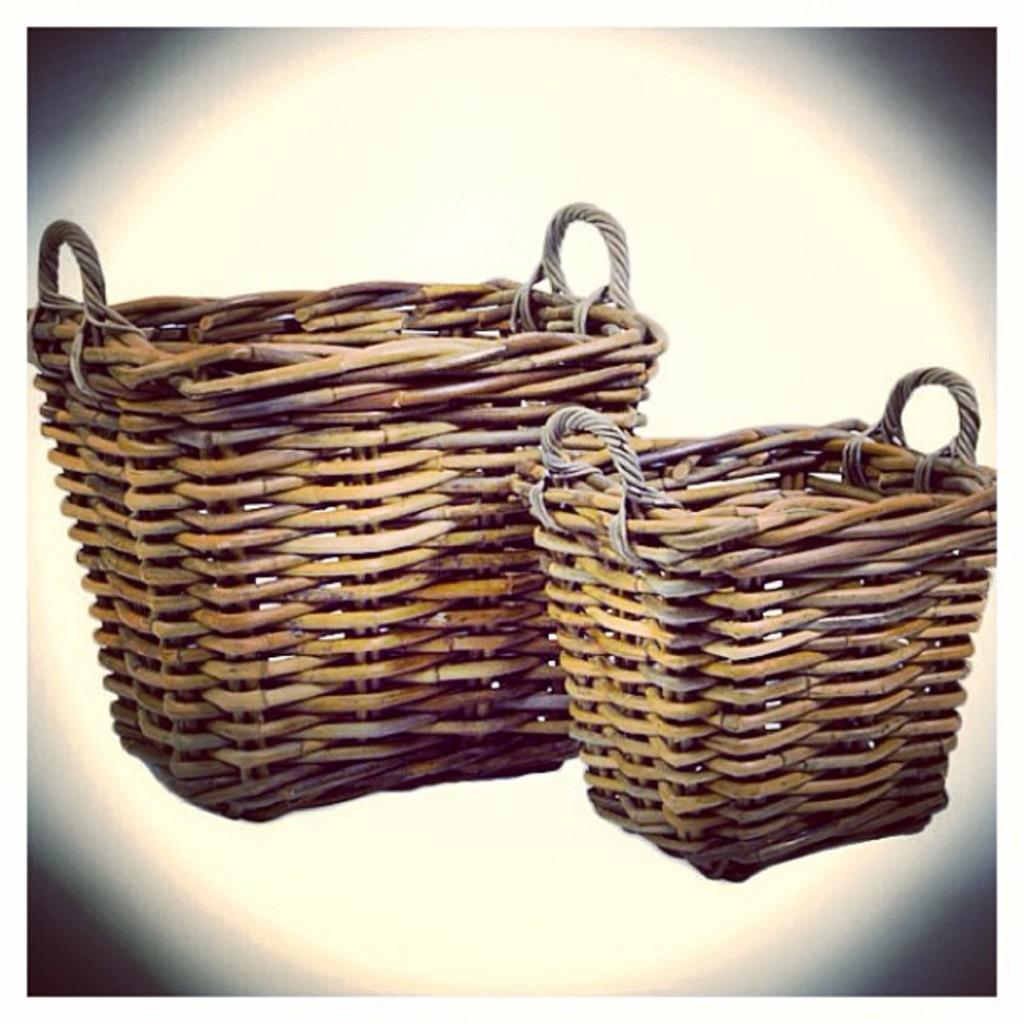Could you give a brief overview of what you see in this image? This is an edited image. I can see two baskets with handles. 